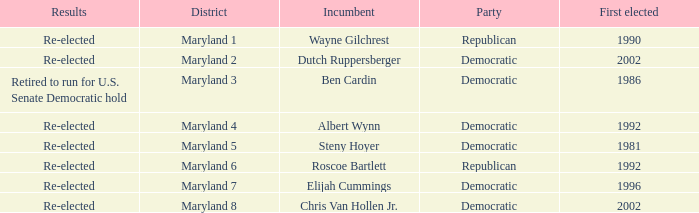What are the results of the incumbent who was first elected in 1996? Re-elected. 